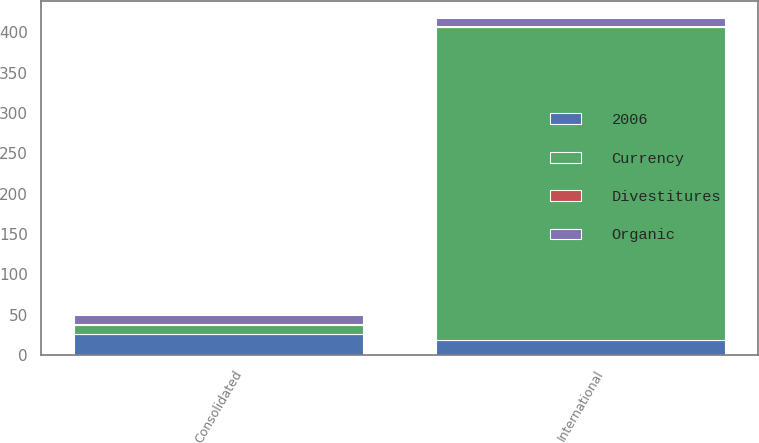Convert chart to OTSL. <chart><loc_0><loc_0><loc_500><loc_500><stacked_bar_chart><ecel><fcel>Consolidated<fcel>International<nl><fcel>Currency<fcel>11.2<fcel>387.7<nl><fcel>Divestitures<fcel>0.9<fcel>0.9<nl><fcel>Organic<fcel>11.2<fcel>10.7<nl><fcel>2006<fcel>26.3<fcel>18.9<nl></chart> 